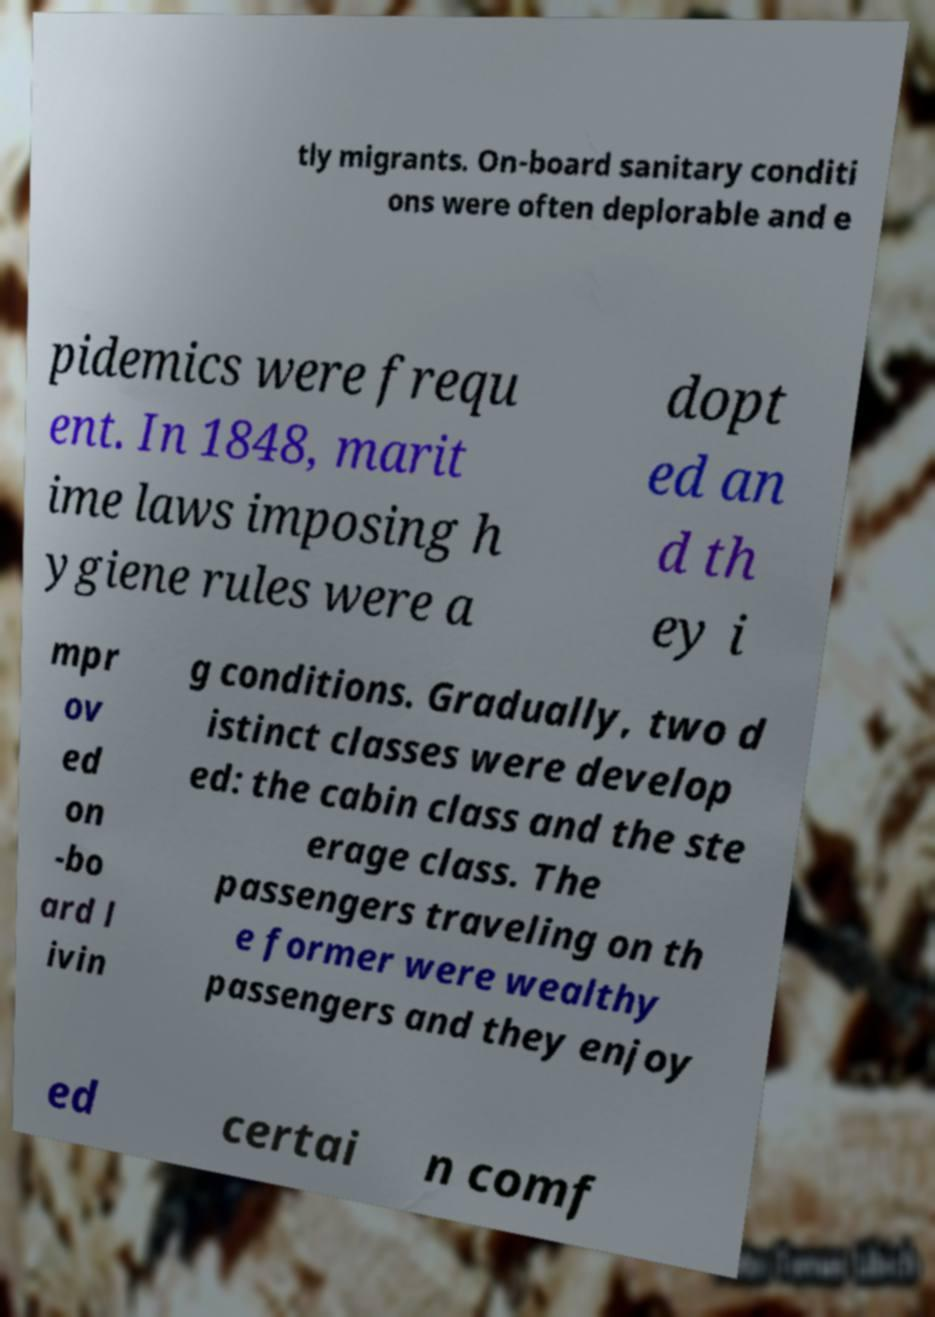I need the written content from this picture converted into text. Can you do that? tly migrants. On-board sanitary conditi ons were often deplorable and e pidemics were frequ ent. In 1848, marit ime laws imposing h ygiene rules were a dopt ed an d th ey i mpr ov ed on -bo ard l ivin g conditions. Gradually, two d istinct classes were develop ed: the cabin class and the ste erage class. The passengers traveling on th e former were wealthy passengers and they enjoy ed certai n comf 